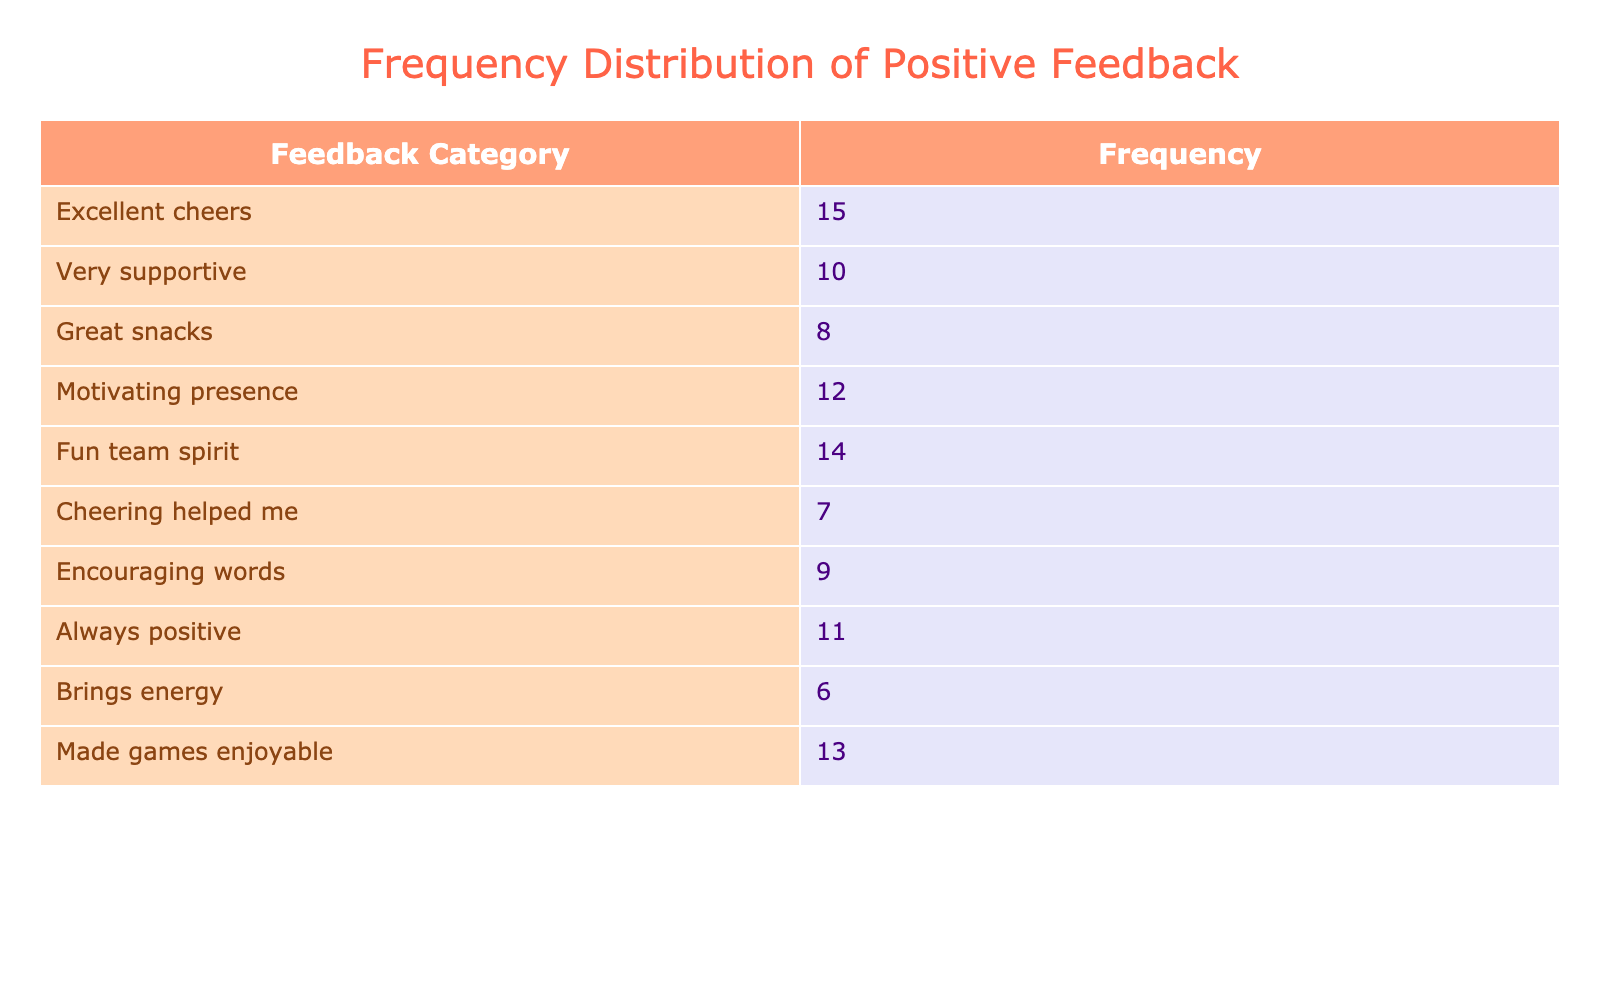What is the most common type of feedback received? The highest frequency count in the table is 15, which corresponds to the "Excellent cheers" feedback category.
Answer: Excellent cheers What is the total frequency of all feedback categories combined? To find the total frequency, we sum all the frequency values: 15 + 10 + 8 + 12 + 14 + 7 + 9 + 11 + 6 + 13 =  95.
Answer: 95 How many feedback categories received a frequency of 10 or more? The feedback categories with 10 or more frequencies are "Excellent cheers", "Very supportive", "Motivating presence", "Fun team spirit", "Always positive", and "Made games enjoyable", making a total of 6 categories.
Answer: 6 What is the difference in frequency between "Great snacks" and "Cheering helped me"? "Great snacks" has a frequency of 8 and "Cheering helped me" has a frequency of 7. The difference is 8 - 7 = 1.
Answer: 1 Did more feedback categories receive a frequency above 10 or below 10? There are 6 feedback categories with a frequency of 10 or more (15, 10, 12, 14, 11, 13) and 4 with below 10 (8, 7, 9, 6). Therefore, more categories received above 10.
Answer: Yes What category had the least frequency and how much was it? The category with the least frequency is "Brings energy" at a frequency of 6, as we can see from the table.
Answer: Brings energy, 6 If we consider only feedback about presence (Motivating presence and Always positive), what is their combined frequency? The combined frequency for "Motivating presence" (12) and "Always positive" (11) is 12 + 11 = 23.
Answer: 23 Which feedback category indicates emotional support and how many feedbacks it received? "Encouraging words" indicates emotional support and it received a frequency of 9, as seen in the table.
Answer: Encouraging words, 9 What is the average frequency of all feedback categories in the table? To calculate the average, we take the total frequency (95) and divide it by the number of feedback categories (10). Thus, the average frequency is 95 / 10 = 9.5.
Answer: 9.5 